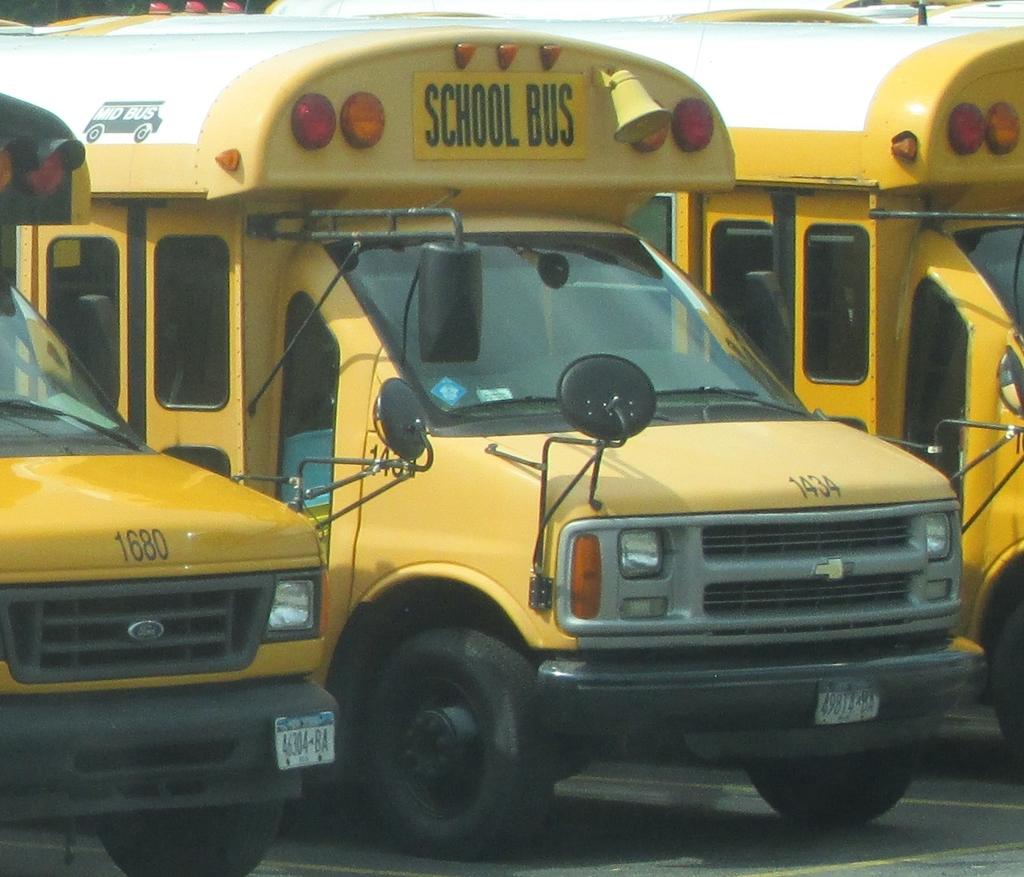What is the number on the front of the left bus?
Give a very brief answer. 1680. What number is the middle bus?
Give a very brief answer. 1434. 